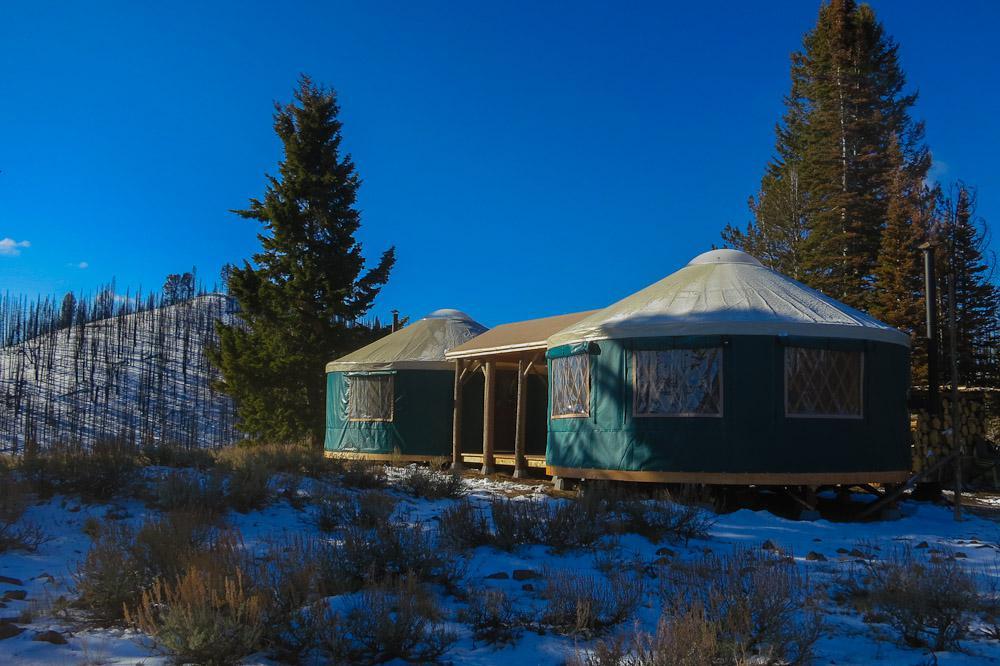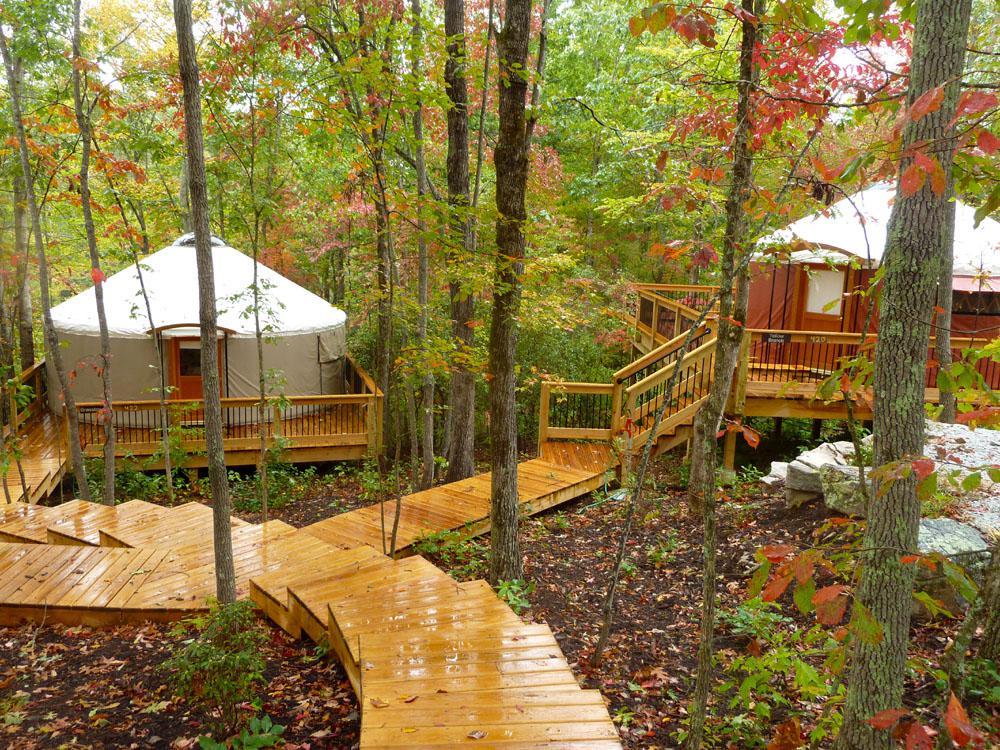The first image is the image on the left, the second image is the image on the right. For the images shown, is this caption "One image contains two round structures wrapped in greenish-blue material and situated among trees." true? Answer yes or no. Yes. The first image is the image on the left, the second image is the image on the right. Considering the images on both sides, is "There are two white huts near each other in the image on the right." valid? Answer yes or no. Yes. 